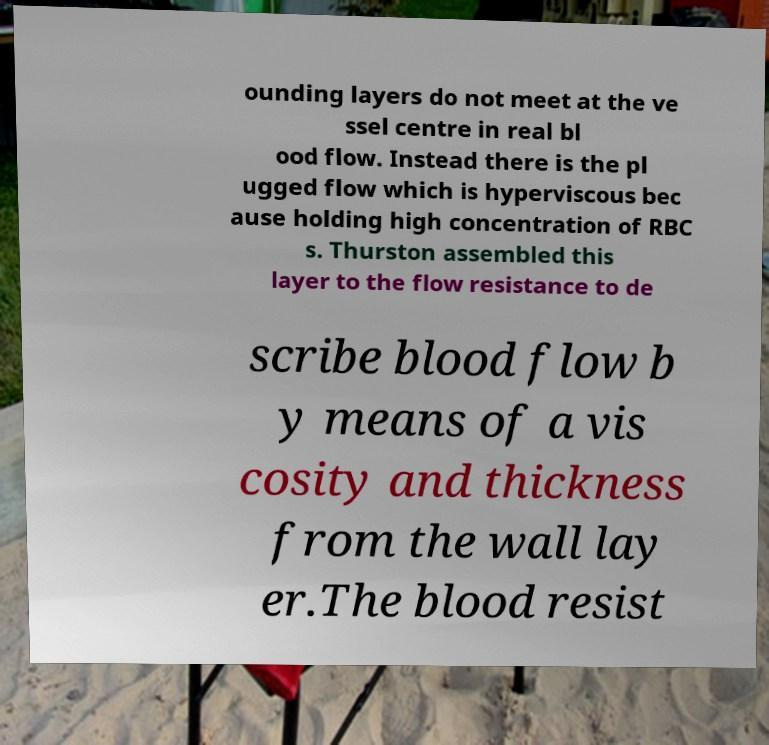Please identify and transcribe the text found in this image. ounding layers do not meet at the ve ssel centre in real bl ood flow. Instead there is the pl ugged flow which is hyperviscous bec ause holding high concentration of RBC s. Thurston assembled this layer to the flow resistance to de scribe blood flow b y means of a vis cosity and thickness from the wall lay er.The blood resist 